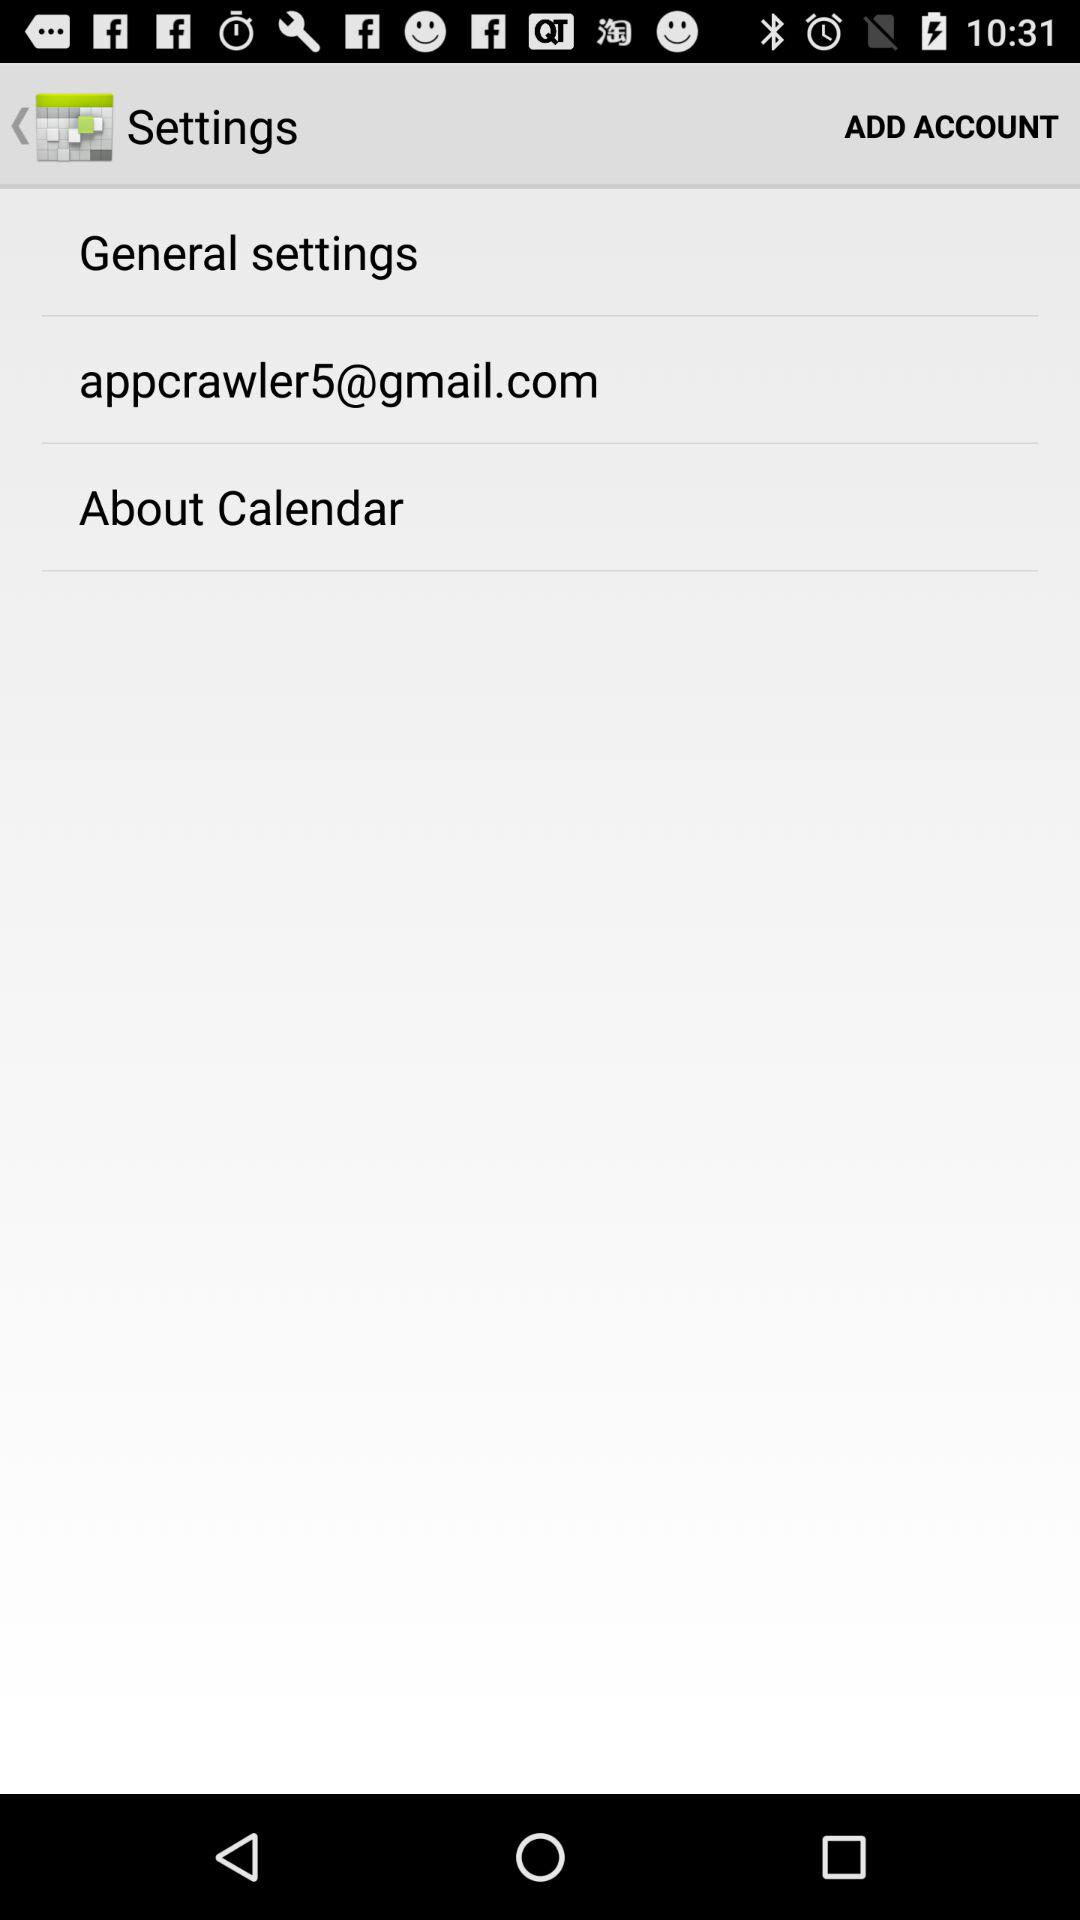What is the status of "General settings"?
When the provided information is insufficient, respond with <no answer>. <no answer> 